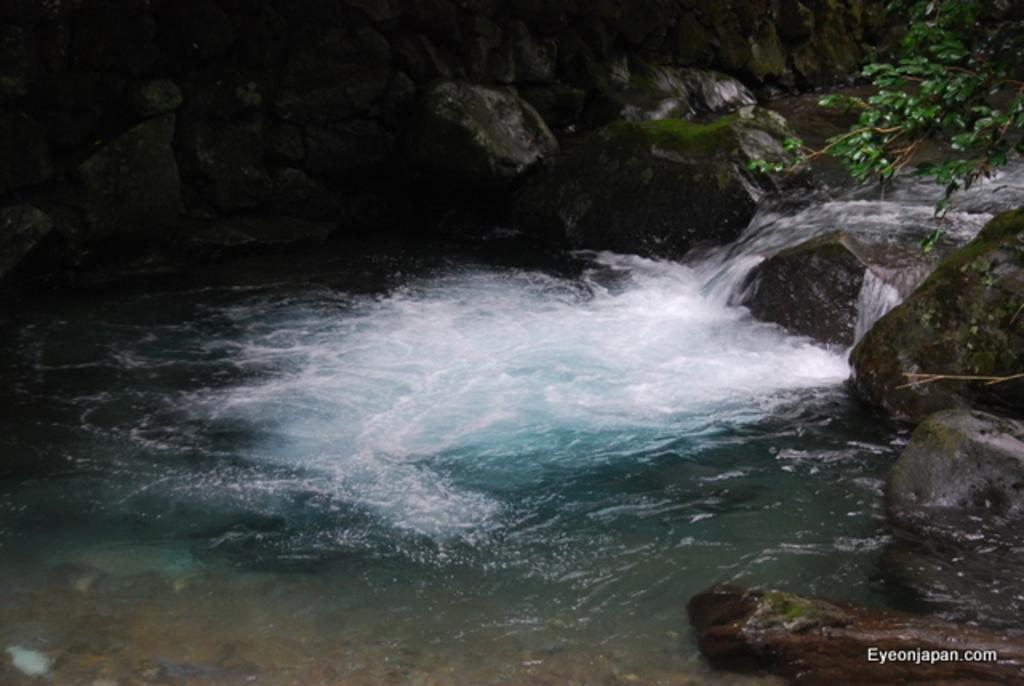What is the primary element visible in the image? There is water in the image. What other objects or features can be seen in the image? There are rocks, branches, and leaves in the image. Is there any text present in the image? Yes, there is text written at the bottom of the image. What type of crime is being committed in the image? There is no crime present in the image; it features water, rocks, branches, leaves, and text. How many muscles can be seen flexing in the image? There are no muscles visible in the image; it does not depict any human or animal figures. 